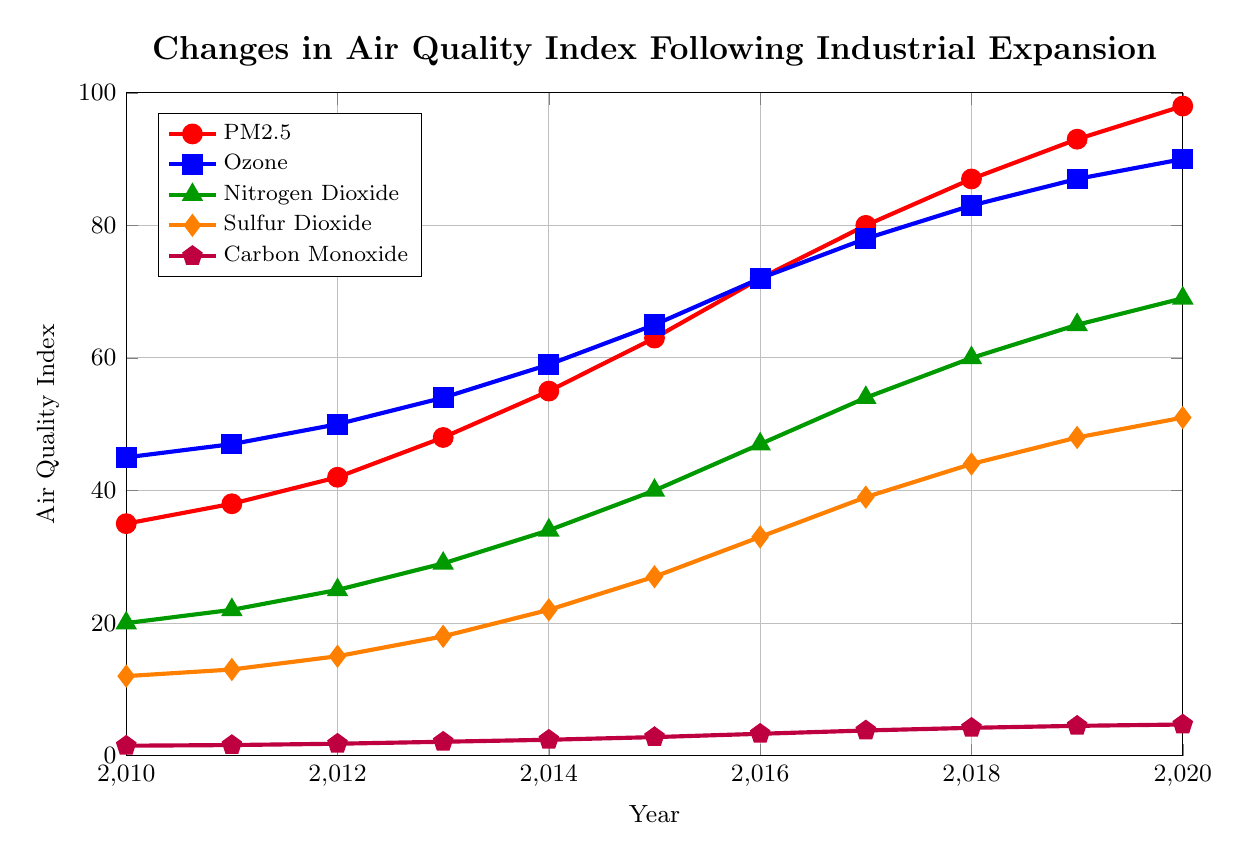What trend can you observe in the levels of PM2.5 from 2010 to 2020? The levels of PM2.5 consistently increase from 2010 to 2020, rising from 35 in 2010 to 98 in 2020.
Answer: Increasing trend In which year did Ozone levels surpass 80 for the first time? By examining the Ozone line, it can be seen that it first goes above 80 in the year 2017.
Answer: 2017 What is the difference in levels of Nitrogen Dioxide between 2010 and 2020? The level of Nitrogen Dioxide in 2010 is 20, and in 2020, it is 69. The difference is calculated as 69 - 20.
Answer: 49 Which pollutant shows the smallest increase from 2010 to 2020? Carbon Monoxide shows an increase from 1.5 in 2010 to 4.7 in 2020. By comparing all increases, it is evident that Carbon Monoxide has the smallest increase.
Answer: Carbon Monoxide During which year are the PM2.5 and Ozone levels closest to each other? By comparing the values for PM2.5 and Ozone each year, in 2019, PM2.5 is 93 and Ozone is 87. The absolute difference is 6, the smallest compared to other years.
Answer: 2019 What is the sum of all pollutant levels in the year 2015? PM2.5: 63, Ozone: 65, Nitrogen Dioxide: 40, Sulfur Dioxide: 27, Carbon Monoxide: 2.8. Sum = 63 + 65 + 40 + 27 + 2.8 = 197.8
Answer: 197.8 Which pollutant had the highest average level from 2010 to 2020? Calculate the average level for each pollutant. PM2.5: (35+38+42+48+55+63+72+80+87+93+98)/11 = 61.45, Ozone: (45+47+50+54+59+65+72+78+83+87+90)/11 = 65.45, Nitrogen Dioxide: (20+22+25+29+34+40+47+54+60+65+69)/11 = 42.64, Sulfur Dioxide: (12+13+15+18+22+27+33+39+44+48+51)/11 = 29, Carbon Monoxide: (1.5+1.6+1.8+2.1+2.4+2.8+3.3+3.8+4.2+4.5+4.7)/11 = 3.00. Ozone has the highest average level.
Answer: Ozone By how much did Sulfur Dioxide levels increase from 2013 to 2018? Sulfur Dioxide level in 2013: 18, in 2018: 44. The increase is calculated as 44 - 18.
Answer: 26 Which pollutant showed the highest level in 2020, and what was this level? The levels in 2020: PM2.5: 98, Ozone: 90, Nitrogen Dioxide: 69, Sulfur Dioxide: 51, Carbon Monoxide: 4.7. PM2.5 has the highest level of 98.
Answer: PM2.5, 98 